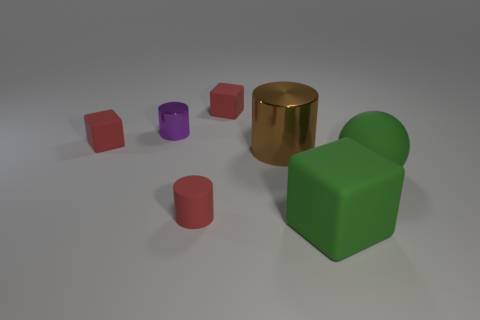Subtract all brown cylinders. How many cylinders are left? 2 Subtract all red cylinders. How many cylinders are left? 2 Subtract all blocks. How many objects are left? 4 Add 2 small rubber cubes. How many objects exist? 9 Subtract all green matte objects. Subtract all purple metallic cylinders. How many objects are left? 4 Add 4 green objects. How many green objects are left? 6 Add 2 large green matte balls. How many large green matte balls exist? 3 Subtract 2 red cubes. How many objects are left? 5 Subtract 2 cylinders. How many cylinders are left? 1 Subtract all brown cylinders. Subtract all gray cubes. How many cylinders are left? 2 